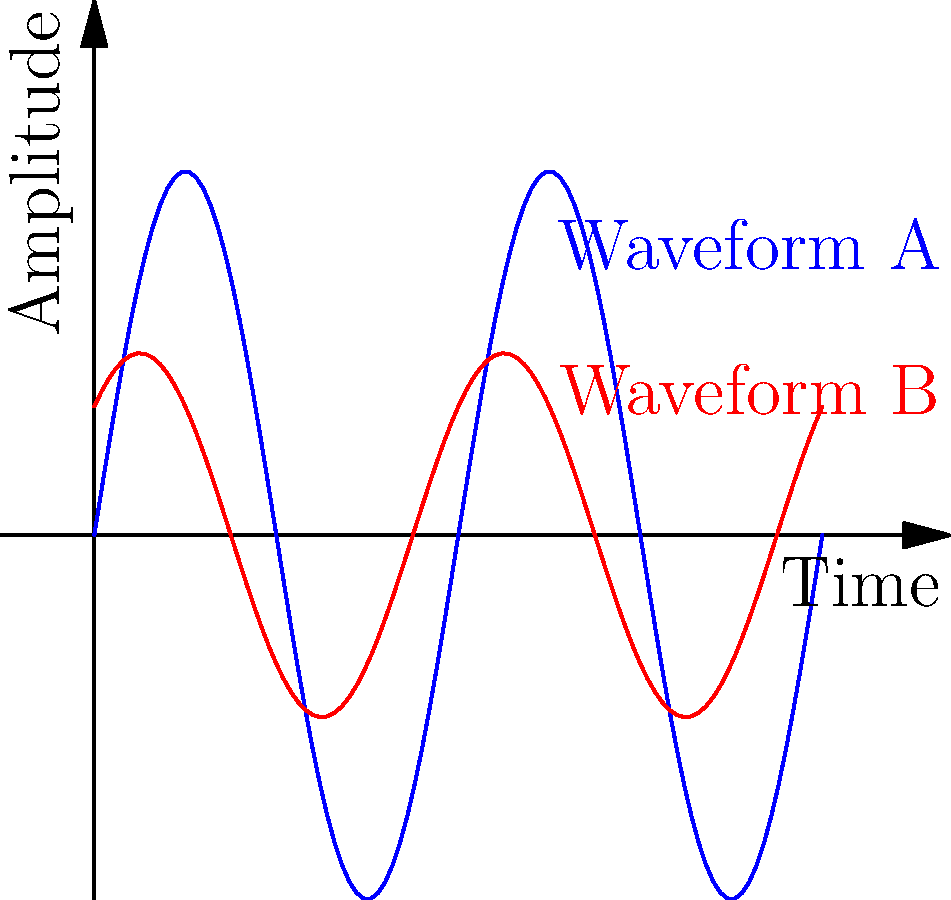As a music producer, you're analyzing two audio waveforms from different recordings. The blue waveform (A) represents a reference track, while the red waveform (B) is from a new recording. Are these waveforms congruent, and if not, what transformations would make them congruent? To determine if the waveforms are congruent and identify necessary transformations, we need to analyze their shape, amplitude, and phase:

1. Shape: Both waveforms appear to be sinusoidal, which is a good start for potential congruence.

2. Amplitude: Waveform A (blue) has a peak-to-peak amplitude of 2 units, while Waveform B (red) has a peak-to-peak amplitude of 1 unit. This indicates that Waveform B has half the amplitude of Waveform A.

3. Phase: Waveform B appears to be shifted slightly to the left compared to Waveform A, indicating a phase difference.

4. Frequency: Both waveforms complete two full cycles in the given time frame, suggesting they have the same frequency.

To make these waveforms congruent:

1. Amplitude scaling: Multiply Waveform B by a factor of 2 to match Waveform A's amplitude.
2. Phase shift: Apply a phase shift to Waveform B to align its peaks and troughs with Waveform A. The shift appears to be approximately $\frac{\pi}{4}$ radians or 45 degrees.

Mathematically, if Waveform A is represented by $f(x) = \sin(2\pi x)$, then Waveform B can be represented by $g(x) = 0.5\sin(2\pi x + \frac{\pi}{4})$.

To make them congruent, transform Waveform B to: $2 \cdot 0.5\sin(2\pi x + \frac{\pi}{4} - \frac{\pi}{4}) = \sin(2\pi x)$, which is identical to Waveform A.
Answer: Not congruent; requires 2x amplitude scaling and $-\frac{\pi}{4}$ phase shift 